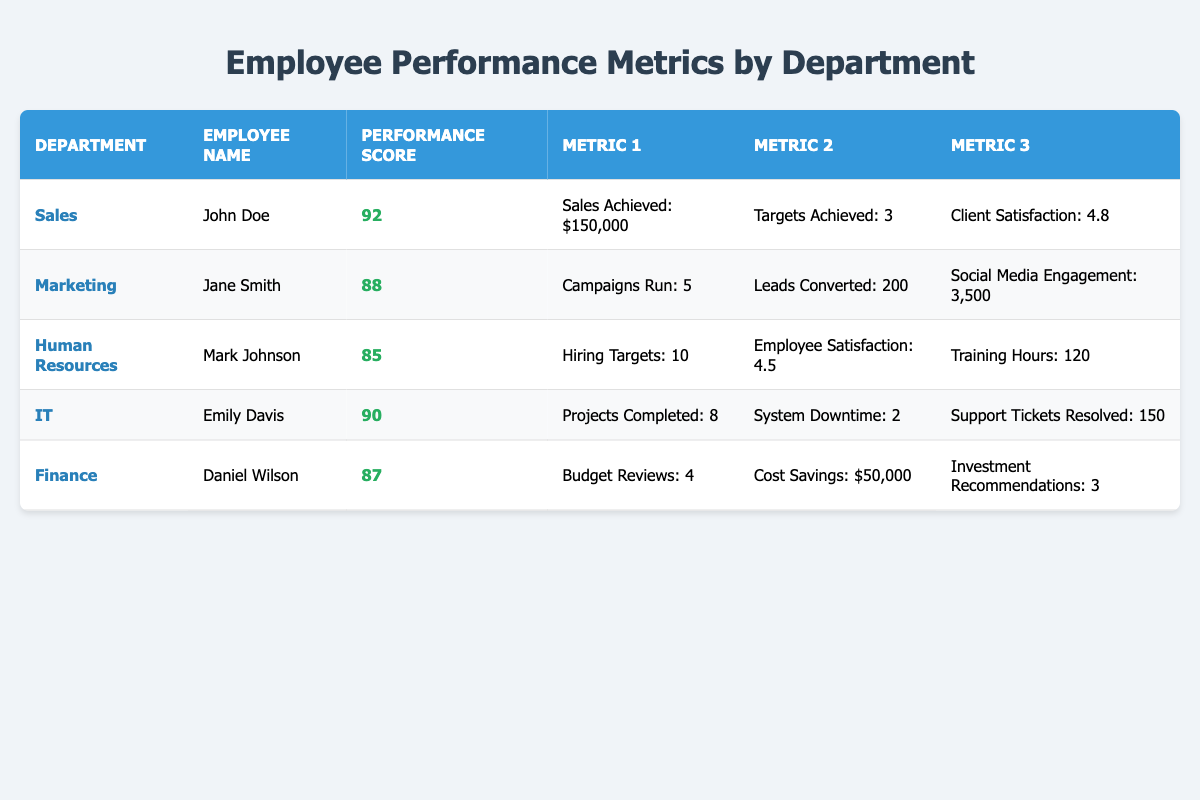What is the highest performance score in the table? By examining the "Performance Score" column, the highest value is 92, which belongs to the employee John Doe in the Sales department.
Answer: 92 Which department has the lowest employee satisfaction rating? Looking at the available metrics, "Employee Satisfaction Rating" is present only in the Human Resources row, and it has a value of 4.5, which is the only satisfaction metric available, making it the lowest.
Answer: 4.5 How many sales did John Doe achieve? John Doe's entry in the table specifies that his "Sales Achieved" is $150,000.
Answer: $150,000 What are the total leads converted by both Marketing and Finance departments? The Marketing department shows 200 leads converted, while the Finance department does not have this metric listed. Thus, the total is simply 200.
Answer: 200 Is Mark Johnson's performance score higher than Emily Davis's? Comparing the "Performance Score" of Mark Johnson (85) with Emily Davis (90), it is clear that 85 is less than 90.
Answer: No What is the average performance score of the employees listed in the table? To find the average performance score, sum the performance scores: 92 + 88 + 85 + 90 + 87 = 442. There are 5 employees, so the average is 442 / 5 = 88.4.
Answer: 88.4 Which department has the highest client satisfaction rating, and what is that rating? The only department that lists a Client Satisfaction Rating is Sales with a score of 4.8, which is the highest compared to other departments that do not have this metric.
Answer: Sales, 4.8 Did any employee achieve more than 10 hiring targets? Referring to the table, the only employee with a hiring metric is Mark Johnson from Human Resources, and he achieved 10 targets, meaning no one exceeded this value.
Answer: No How many total projects were completed by the IT department? The IT department's entry shows that the number of completed projects is 8.
Answer: 8 